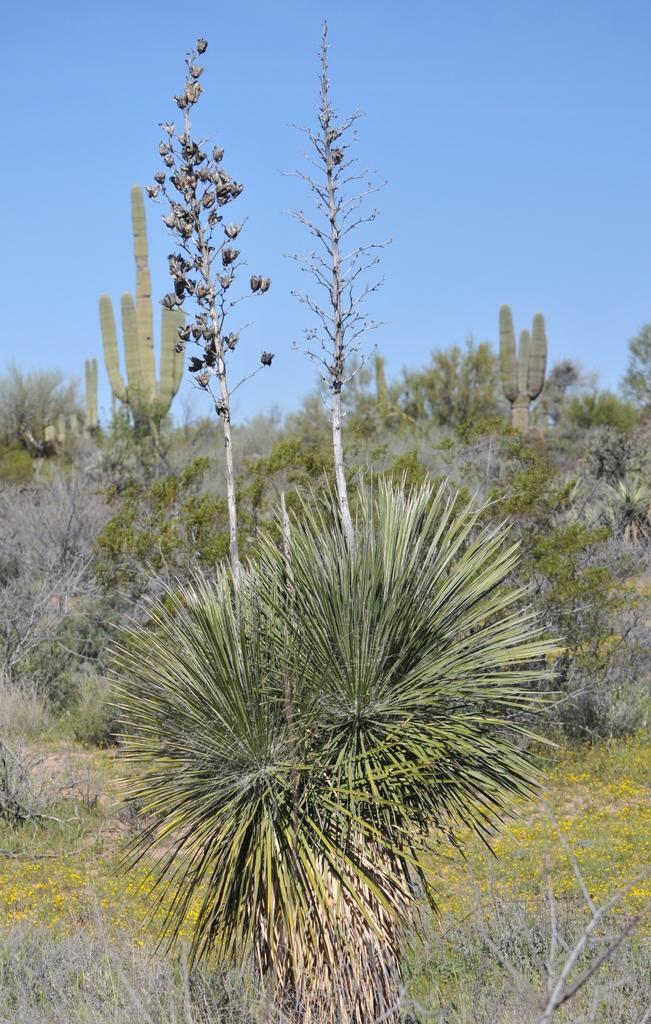What colors are the trees in the image? The trees in the image have green and grey colors. What color is the sky in the image? The sky is blue in the image. What type of rake is being used to show the weather in the image? There is no rake or indication of weather in the image; it only features trees and a blue sky. 